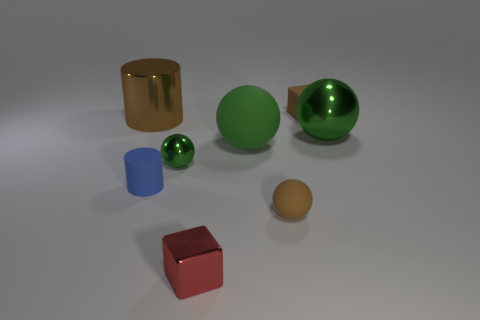Subtract all purple cylinders. How many green spheres are left? 3 Subtract all brown balls. How many balls are left? 3 Subtract all large green matte spheres. How many spheres are left? 3 Subtract all purple spheres. Subtract all brown cylinders. How many spheres are left? 4 Add 1 small red metallic cubes. How many objects exist? 9 Subtract 0 purple spheres. How many objects are left? 8 Subtract all cylinders. How many objects are left? 6 Subtract all big blue things. Subtract all large green metal balls. How many objects are left? 7 Add 2 brown objects. How many brown objects are left? 5 Add 8 tiny brown matte things. How many tiny brown matte things exist? 10 